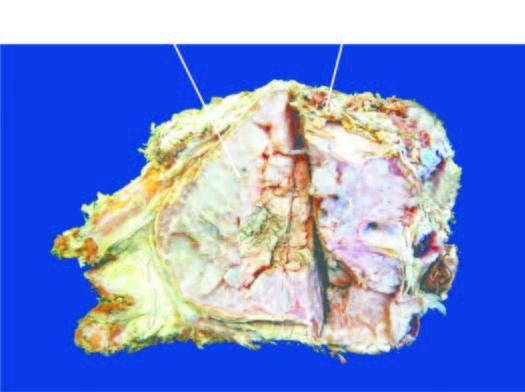s the bone expanded externally due to a gelatinous tumour?
Answer the question using a single word or phrase. Yes 